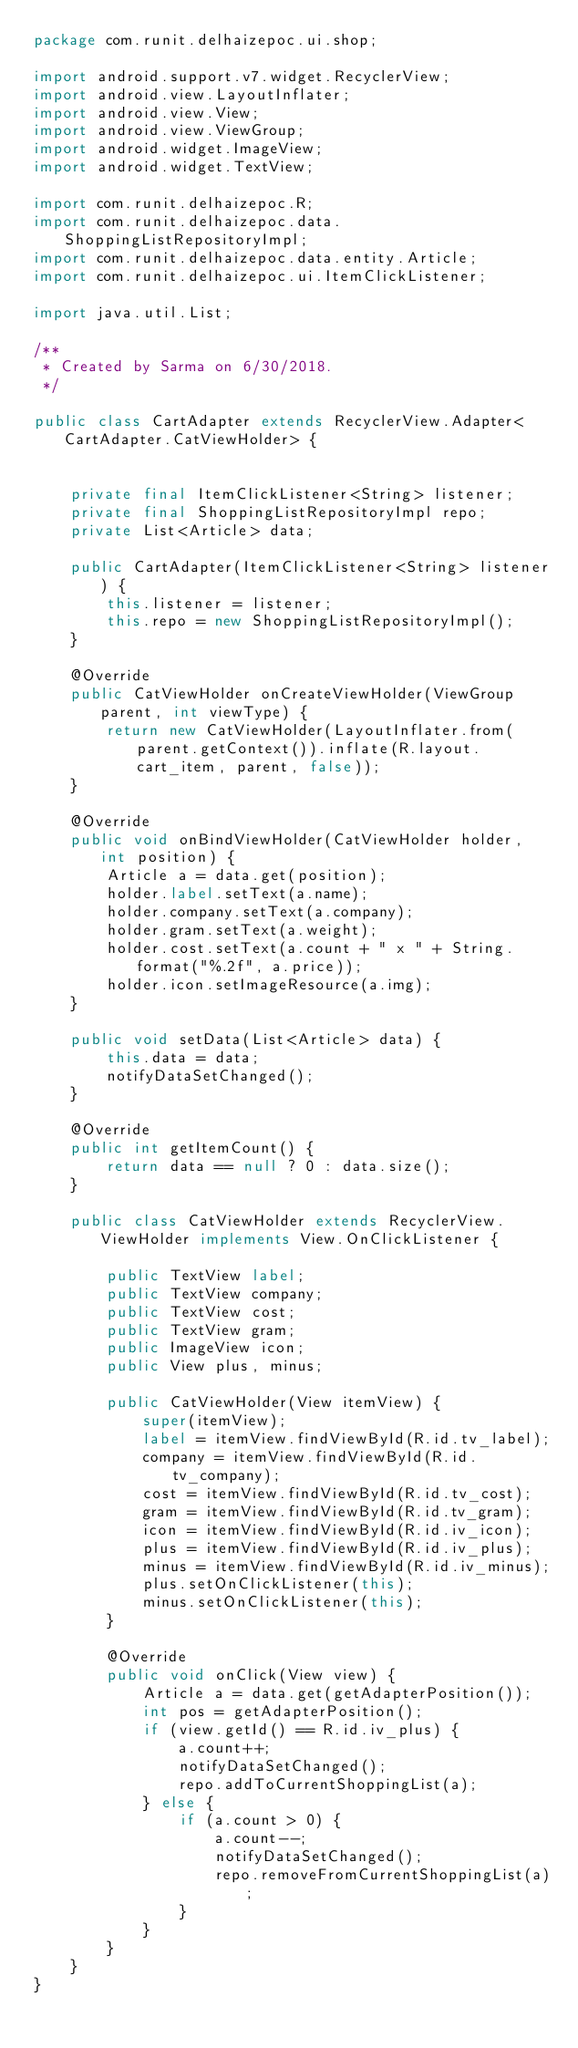Convert code to text. <code><loc_0><loc_0><loc_500><loc_500><_Java_>package com.runit.delhaizepoc.ui.shop;

import android.support.v7.widget.RecyclerView;
import android.view.LayoutInflater;
import android.view.View;
import android.view.ViewGroup;
import android.widget.ImageView;
import android.widget.TextView;

import com.runit.delhaizepoc.R;
import com.runit.delhaizepoc.data.ShoppingListRepositoryImpl;
import com.runit.delhaizepoc.data.entity.Article;
import com.runit.delhaizepoc.ui.ItemClickListener;

import java.util.List;

/**
 * Created by Sarma on 6/30/2018.
 */

public class CartAdapter extends RecyclerView.Adapter<CartAdapter.CatViewHolder> {


    private final ItemClickListener<String> listener;
    private final ShoppingListRepositoryImpl repo;
    private List<Article> data;

    public CartAdapter(ItemClickListener<String> listener) {
        this.listener = listener;
        this.repo = new ShoppingListRepositoryImpl();
    }

    @Override
    public CatViewHolder onCreateViewHolder(ViewGroup parent, int viewType) {
        return new CatViewHolder(LayoutInflater.from(parent.getContext()).inflate(R.layout.cart_item, parent, false));
    }

    @Override
    public void onBindViewHolder(CatViewHolder holder, int position) {
        Article a = data.get(position);
        holder.label.setText(a.name);
        holder.company.setText(a.company);
        holder.gram.setText(a.weight);
        holder.cost.setText(a.count + " x " + String.format("%.2f", a.price));
        holder.icon.setImageResource(a.img);
    }

    public void setData(List<Article> data) {
        this.data = data;
        notifyDataSetChanged();
    }

    @Override
    public int getItemCount() {
        return data == null ? 0 : data.size();
    }

    public class CatViewHolder extends RecyclerView.ViewHolder implements View.OnClickListener {

        public TextView label;
        public TextView company;
        public TextView cost;
        public TextView gram;
        public ImageView icon;
        public View plus, minus;

        public CatViewHolder(View itemView) {
            super(itemView);
            label = itemView.findViewById(R.id.tv_label);
            company = itemView.findViewById(R.id.tv_company);
            cost = itemView.findViewById(R.id.tv_cost);
            gram = itemView.findViewById(R.id.tv_gram);
            icon = itemView.findViewById(R.id.iv_icon);
            plus = itemView.findViewById(R.id.iv_plus);
            minus = itemView.findViewById(R.id.iv_minus);
            plus.setOnClickListener(this);
            minus.setOnClickListener(this);
        }

        @Override
        public void onClick(View view) {
            Article a = data.get(getAdapterPosition());
            int pos = getAdapterPosition();
            if (view.getId() == R.id.iv_plus) {
                a.count++;
                notifyDataSetChanged();
                repo.addToCurrentShoppingList(a);
            } else {
                if (a.count > 0) {
                    a.count--;
                    notifyDataSetChanged();
                    repo.removeFromCurrentShoppingList(a);
                }
            }
        }
    }
}
</code> 